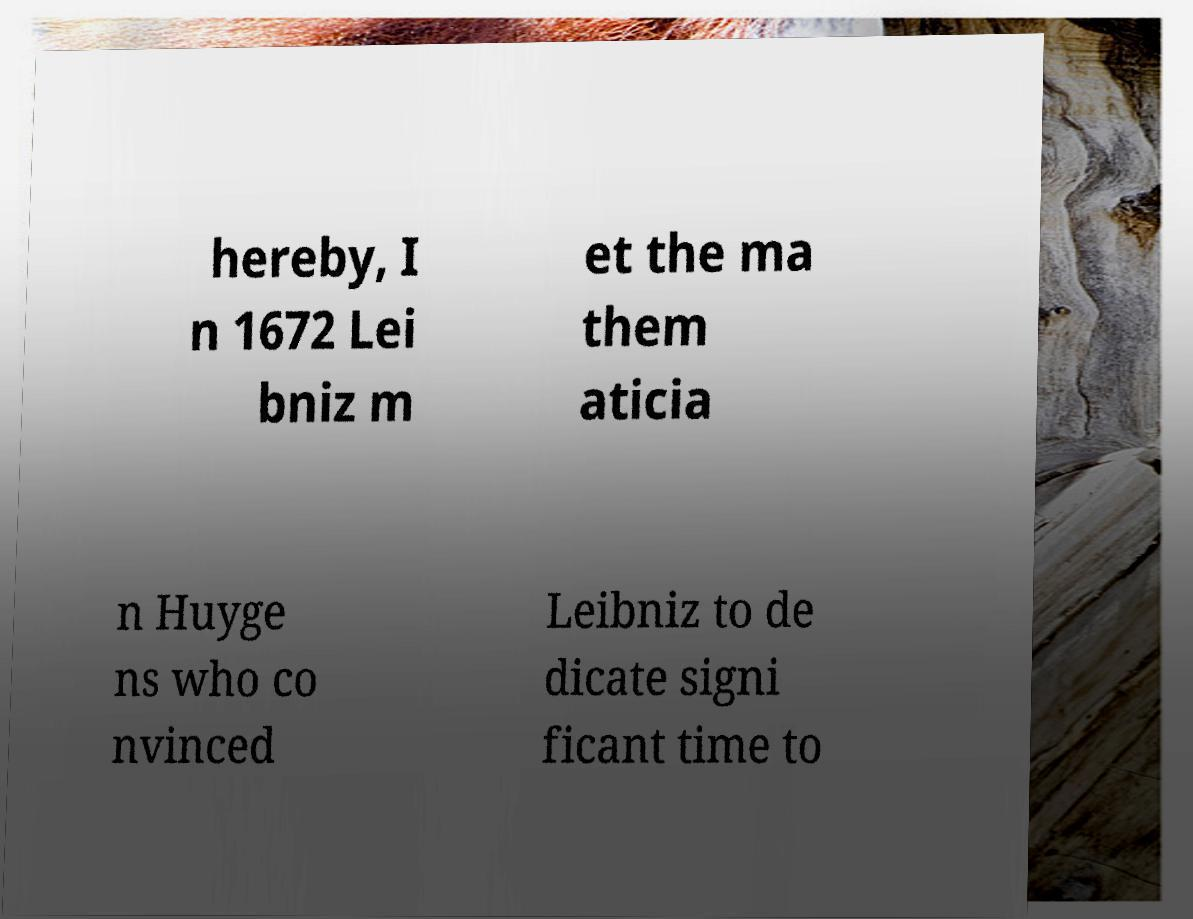I need the written content from this picture converted into text. Can you do that? hereby, I n 1672 Lei bniz m et the ma them aticia n Huyge ns who co nvinced Leibniz to de dicate signi ficant time to 